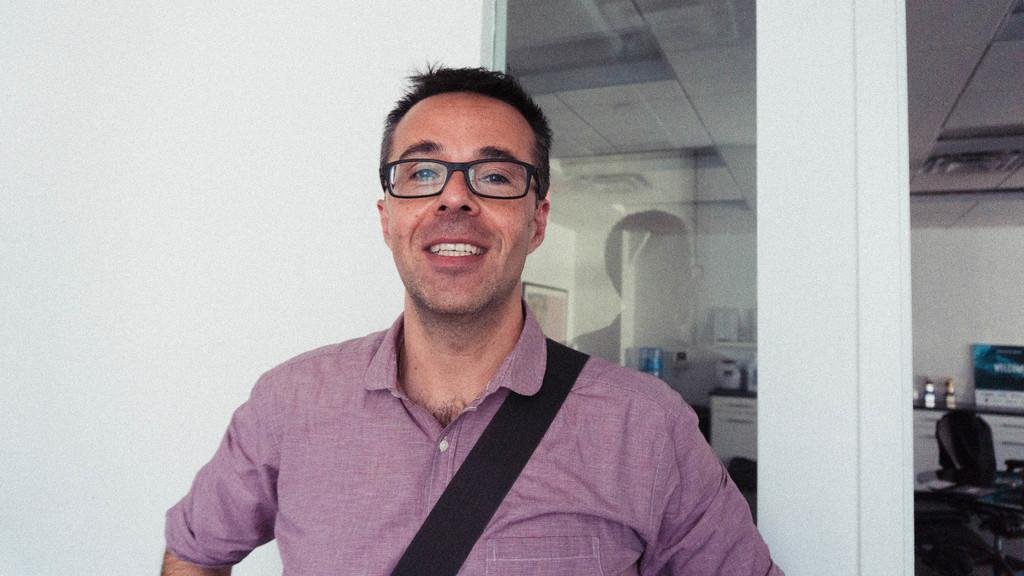Who is present in the image? There is a person in the image. What is the person's facial expression? The person is smiling. What is the person wearing? The person is wearing a bag. What can be seen in the background of the image? There is a chair, glass doors, and objects on a table in the background of the image. What color is the wall visible in the image? There is a white wall visible in the image. Where is the playground located in the image? There is no playground present in the image. What type of friction is visible between the person and the chair in the image? There is no friction visible between the person and the chair in the image, as the person is not interacting with the chair. 